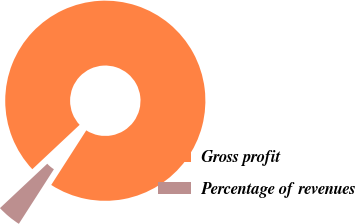Convert chart. <chart><loc_0><loc_0><loc_500><loc_500><pie_chart><fcel>Gross profit<fcel>Percentage of revenues<nl><fcel>96.08%<fcel>3.92%<nl></chart> 